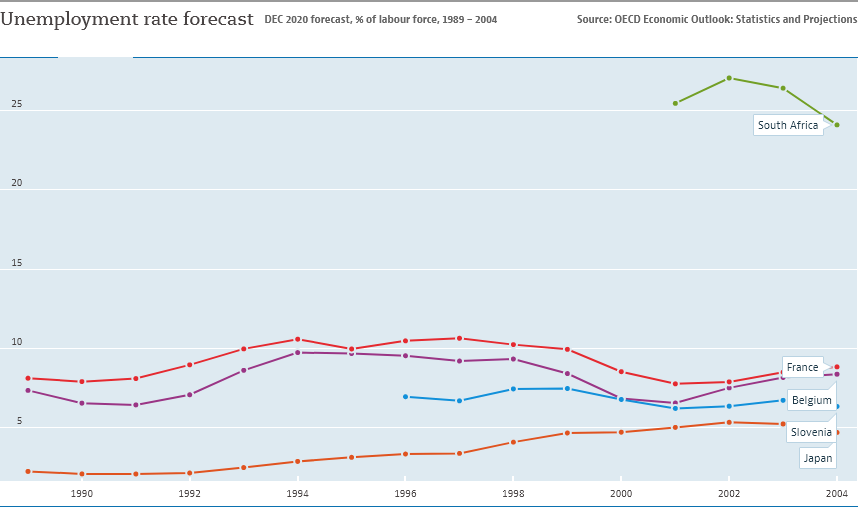Point out several critical features in this image. During the period of time in question, a significant number of countries experienced an unemployment rate of more than 5%. South Africa is represented by the green color line. 